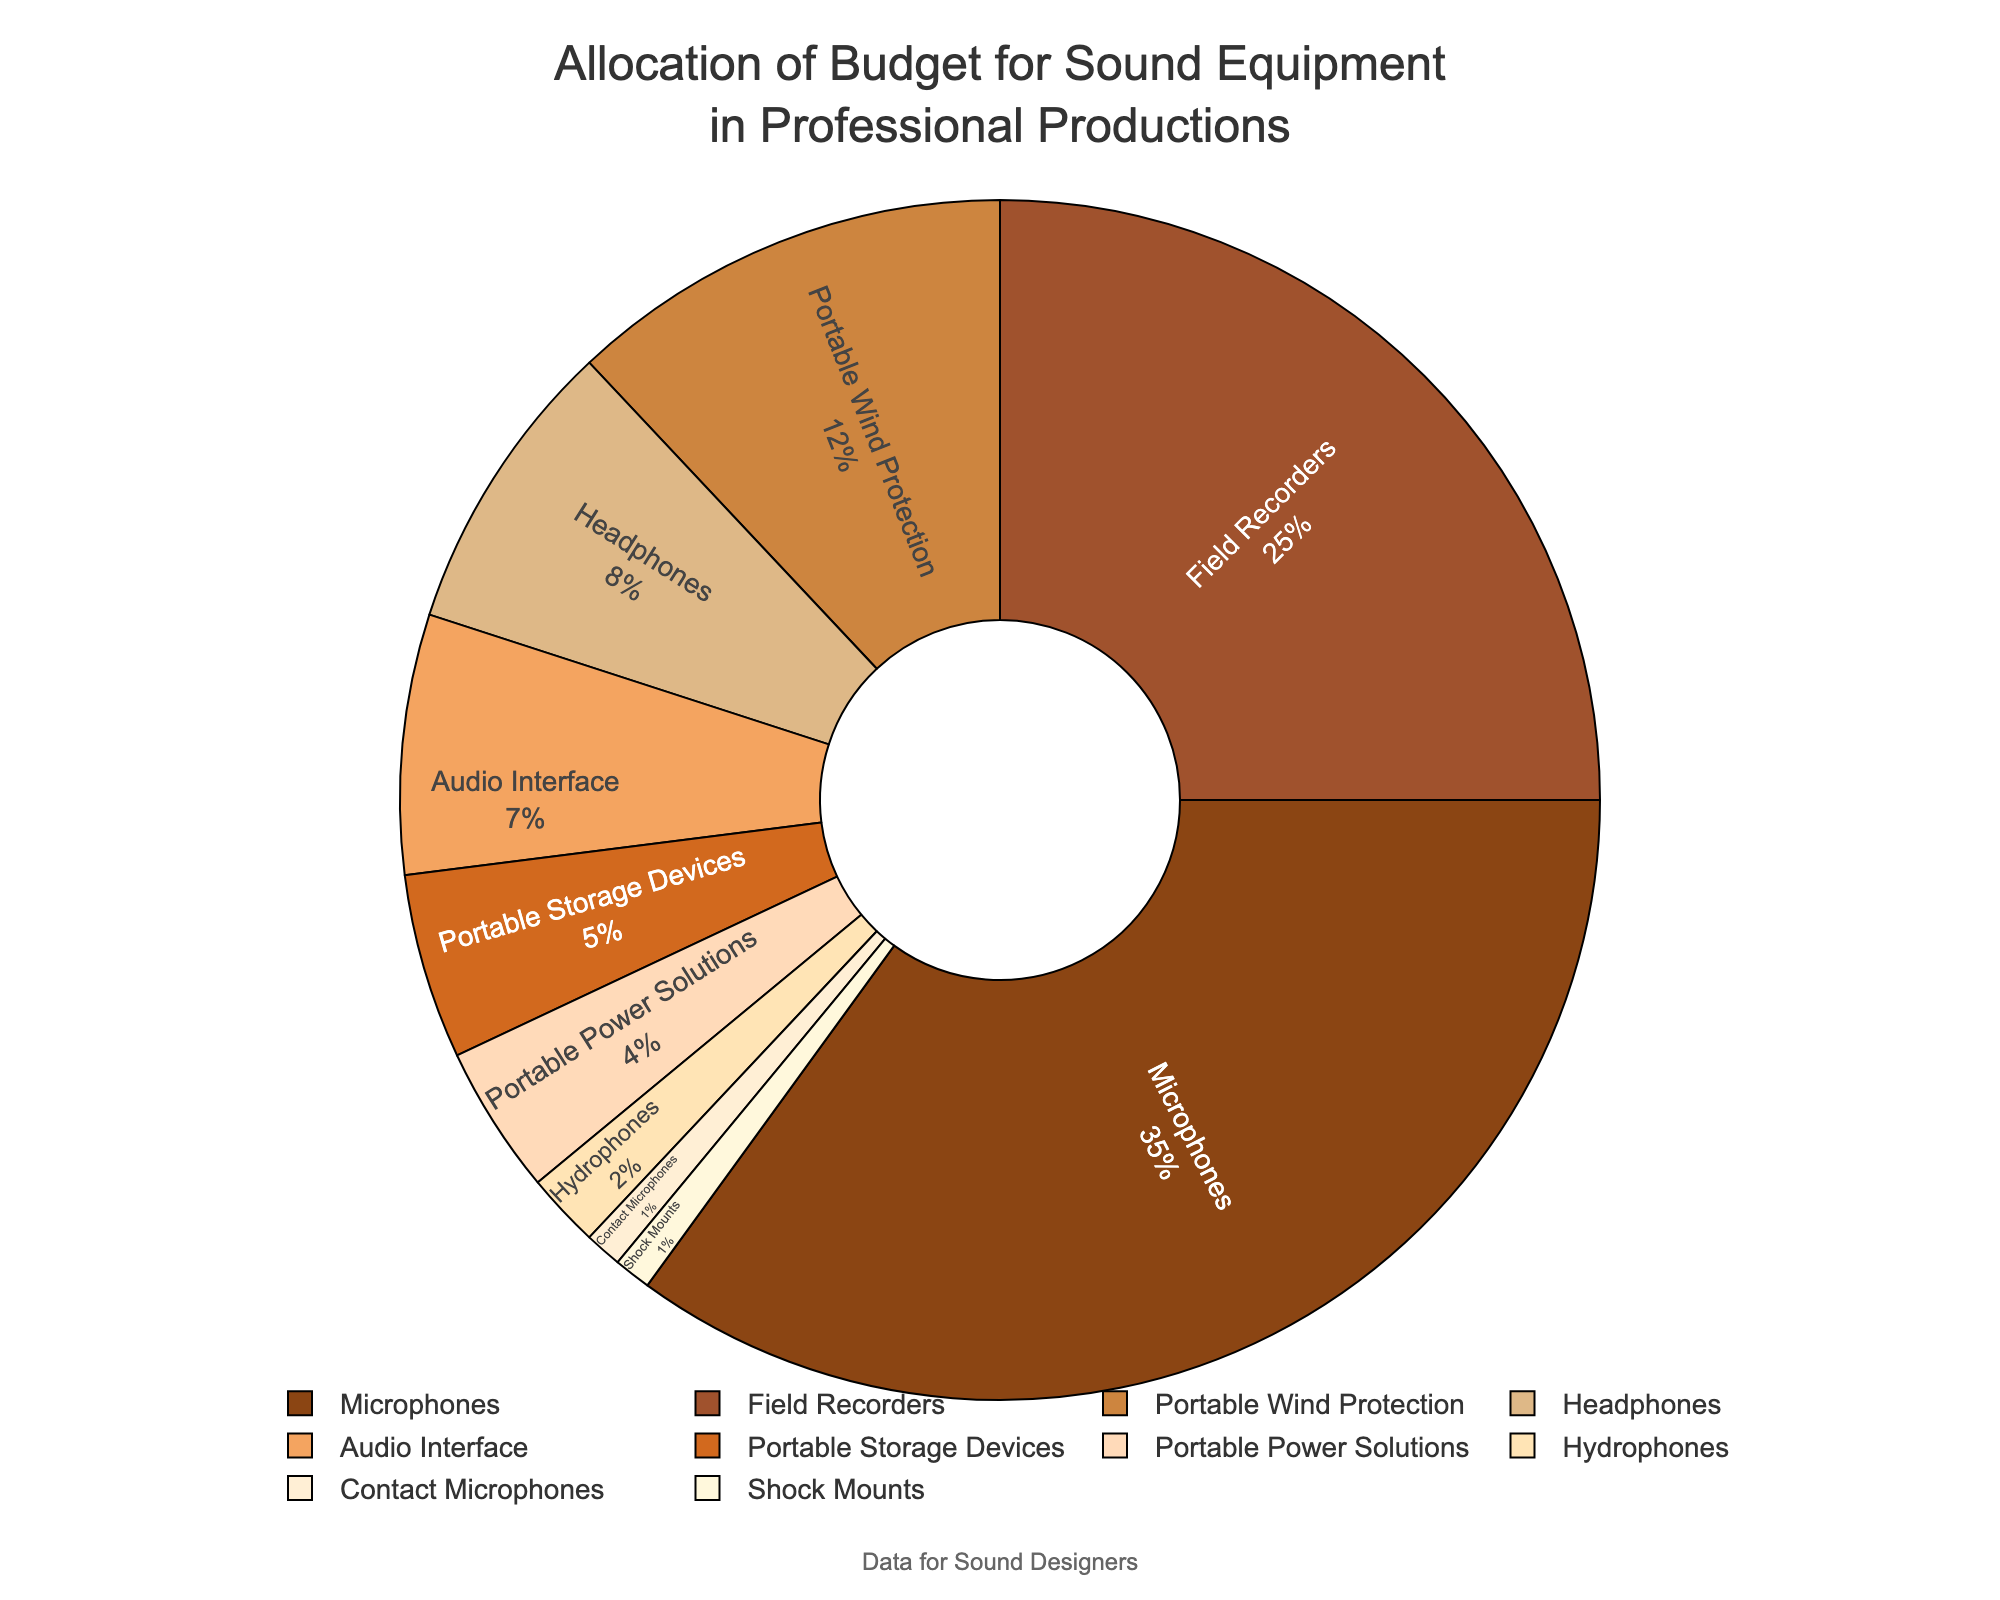What category has the highest percentage allocation? By looking at the pie chart, the largest segment corresponds to the category 'Microphones' with a percentage of 35%.
Answer: Microphones Which two categories combined make up more than half of the budget? Adding the percentages of the top two categories: Microphones (35%) and Field Recorders (25%) gives us a total of 60%, which is more than half.
Answer: Microphones and Field Recorders How much more is allocated to Portable Wind Protection compared to Portable Storage Devices? Portable Wind Protection has 12% and Portable Storage Devices have 5%. Subtracting these gives 12% - 5% = 7%.
Answer: 7% Which category has a smaller allocation, Hydrophones or Contact Microphones? Both Hydrophones and Contact Microphones are small portions. Hydrophones are at 2% whereas Contact Microphones are at 1%.
Answer: Contact Microphones What is the total percentage allocated to headphones and audio interfaces combined? Adding the percentages of Headphones (8%) and Audio Interface (7%) gives us a total of 8% + 7% = 15%.
Answer: 15% Is the percentage allocated to Portable Power Solutions greater than or equal to Portable Storage Devices? Portable Power Solutions have a 4% allocation, and Portable Storage Devices have 5%. 4% is less than 5%.
Answer: No What is the combined percentage allocation of categories with less than 5%? Categories with less than 5% are Portable Power Solutions (4%), Hydrophones (2%), Contact Microphones (1%), and Shock Mounts (1%). Adding them gives 4% + 2% + 1% + 1% = 8%.
Answer: 8% Rank the categories from highest to lowest percentage allocation. Listing the categories in descending order: Microphones (35%), Field Recorders (25%), Portable Wind Protection (12%), Headphones (8%), Audio Interface (7%), Portable Storage Devices (5%), Portable Power Solutions (4%), Hydrophones (2%), Contact Microphones (1%), and Shock Mounts (1%).
Answer: Microphones, Field Recorders, Portable Wind Protection, Headphones, Audio Interface, Portable Storage Devices, Portable Power Solutions, Hydrophones, Contact Microphones, Shock Mounts Which segment is visually represented in a darker color, Microphones or Headphones? By observing the color palette, Microphones are represented with a darker color compared to Headphones.
Answer: Microphones 